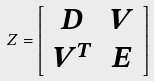Convert formula to latex. <formula><loc_0><loc_0><loc_500><loc_500>Z = \left [ \begin{array} { c c } D & V \\ V ^ { T } & E \end{array} \right ]</formula> 